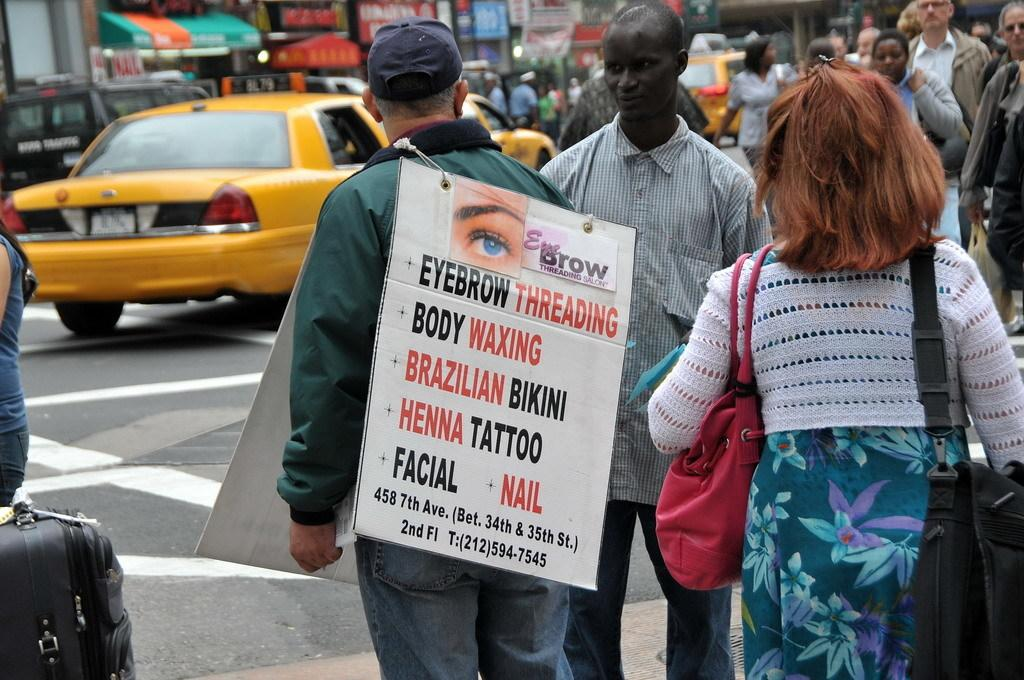<image>
Relay a brief, clear account of the picture shown. A man wears a sandwich board for a beauty shop offering facials, body waxing and eyebrow threading. 